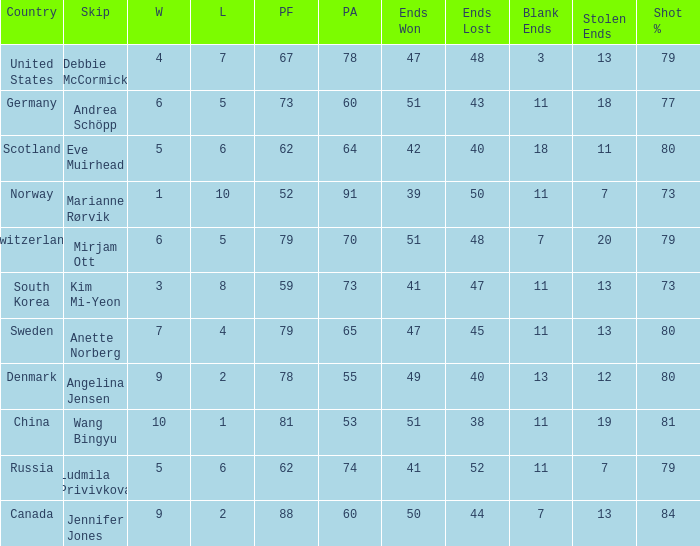When the country was Scotland, how many ends were won? 1.0. 